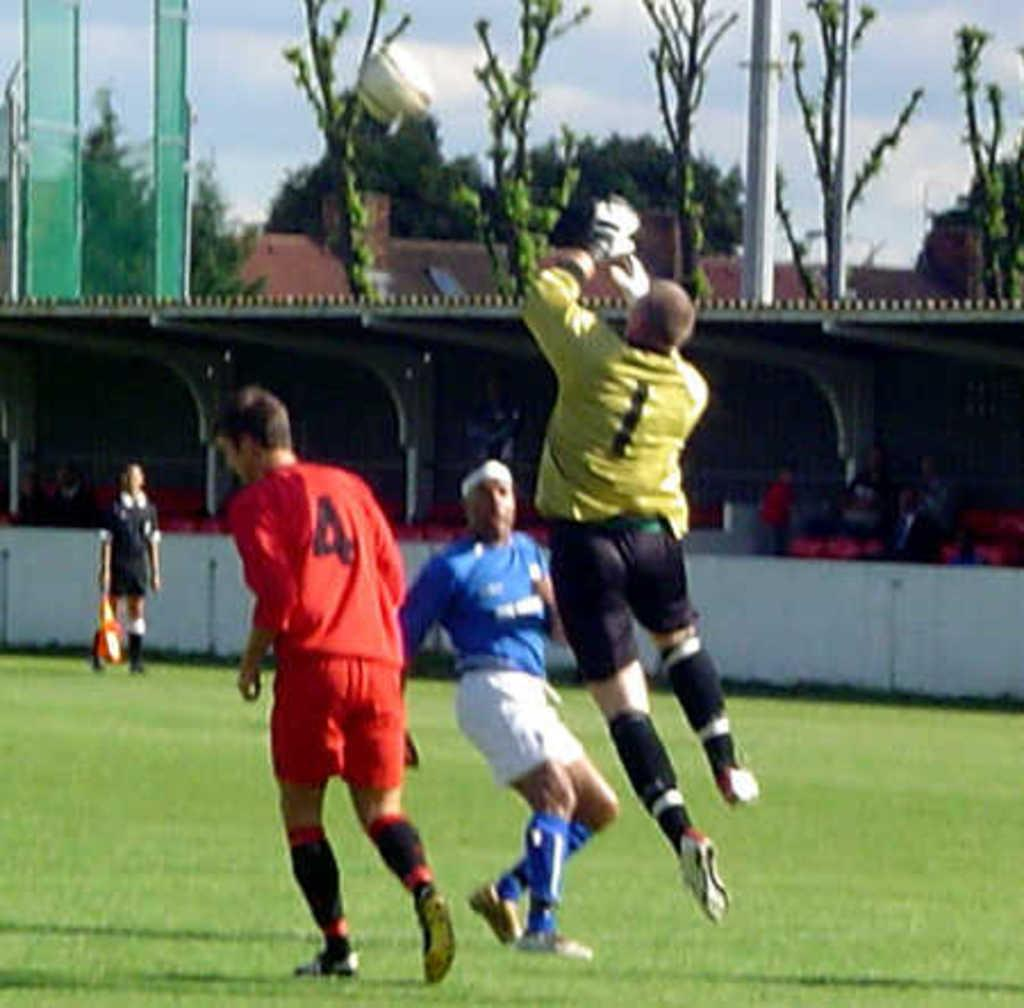<image>
Present a compact description of the photo's key features. The footballer in red has the number 4 on his shirt. 